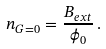<formula> <loc_0><loc_0><loc_500><loc_500>n _ { G = 0 } = \frac { B _ { e x t } } { \phi _ { 0 } } \, .</formula> 